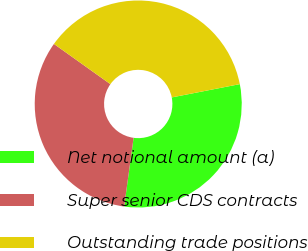<chart> <loc_0><loc_0><loc_500><loc_500><pie_chart><fcel>Net notional amount (a)<fcel>Super senior CDS contracts<fcel>Outstanding trade positions<nl><fcel>30.24%<fcel>32.68%<fcel>37.07%<nl></chart> 